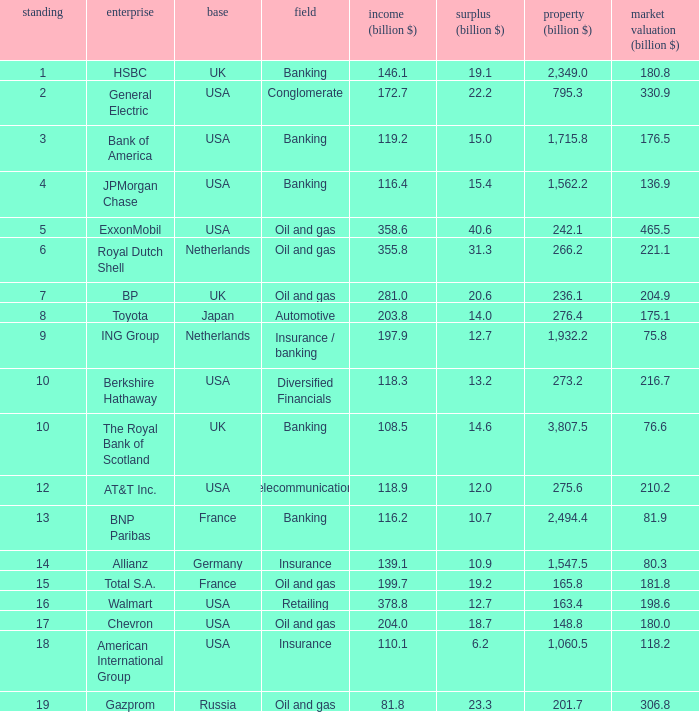Which industry has a company with a market value of 80.3 billion?  Insurance. 